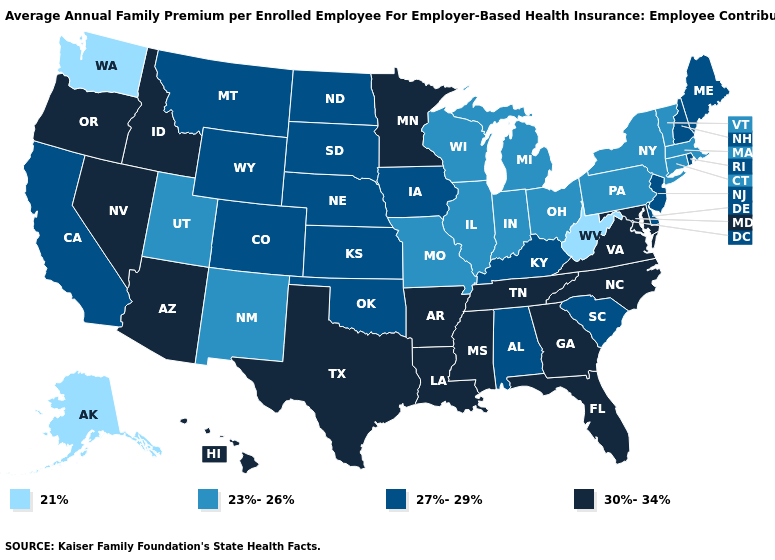What is the highest value in the South ?
Short answer required. 30%-34%. Name the states that have a value in the range 21%?
Quick response, please. Alaska, Washington, West Virginia. Which states have the lowest value in the USA?
Write a very short answer. Alaska, Washington, West Virginia. Does the map have missing data?
Concise answer only. No. Does Hawaii have the same value as Connecticut?
Keep it brief. No. Does Maine have the highest value in the USA?
Quick response, please. No. What is the value of Tennessee?
Give a very brief answer. 30%-34%. Name the states that have a value in the range 23%-26%?
Short answer required. Connecticut, Illinois, Indiana, Massachusetts, Michigan, Missouri, New Mexico, New York, Ohio, Pennsylvania, Utah, Vermont, Wisconsin. Which states have the highest value in the USA?
Write a very short answer. Arizona, Arkansas, Florida, Georgia, Hawaii, Idaho, Louisiana, Maryland, Minnesota, Mississippi, Nevada, North Carolina, Oregon, Tennessee, Texas, Virginia. Does the map have missing data?
Be succinct. No. What is the highest value in the Northeast ?
Concise answer only. 27%-29%. What is the value of Montana?
Be succinct. 27%-29%. Does Washington have the highest value in the West?
Write a very short answer. No. What is the value of Nevada?
Give a very brief answer. 30%-34%. What is the highest value in states that border Massachusetts?
Keep it brief. 27%-29%. 